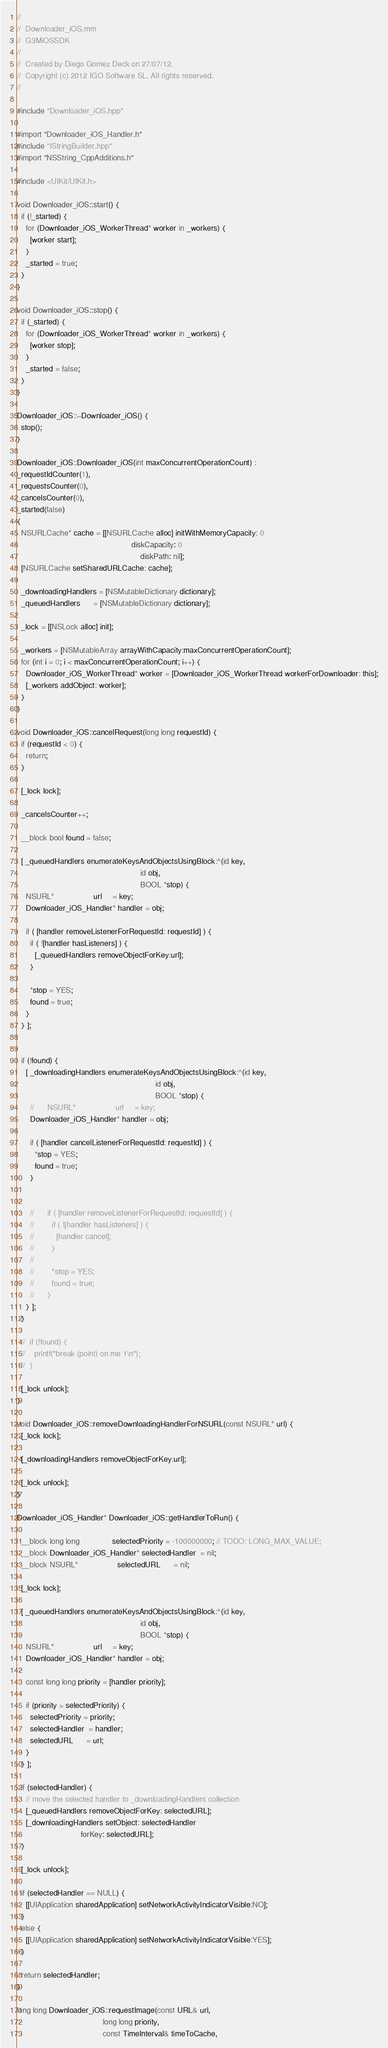<code> <loc_0><loc_0><loc_500><loc_500><_ObjectiveC_>//
//  Downloader_iOS.mm
//  G3MiOSSDK
//
//  Created by Diego Gomez Deck on 27/07/12.
//  Copyright (c) 2012 IGO Software SL. All rights reserved.
//

#include "Downloader_iOS.hpp"

#import "Downloader_iOS_Handler.h"
#include "IStringBuilder.hpp"
#import "NSString_CppAdditions.h"

#include <UIKit/UIKit.h>

void Downloader_iOS::start() {
  if (!_started) {
    for (Downloader_iOS_WorkerThread* worker in _workers) {
      [worker start];
    }
    _started = true;
  }
}

void Downloader_iOS::stop() {
  if (_started) {
    for (Downloader_iOS_WorkerThread* worker in _workers) {
      [worker stop];
    }
    _started = false;
  }
}

Downloader_iOS::~Downloader_iOS() {
  stop();
}

Downloader_iOS::Downloader_iOS(int maxConcurrentOperationCount) :
_requestIdCounter(1),
_requestsCounter(0),
_cancelsCounter(0),
_started(false)
{
  NSURLCache* cache = [[NSURLCache alloc] initWithMemoryCapacity: 0
                                                    diskCapacity: 0
                                                        diskPath: nil];
  [NSURLCache setSharedURLCache: cache];

  _downloadingHandlers = [NSMutableDictionary dictionary];
  _queuedHandlers      = [NSMutableDictionary dictionary];

  _lock = [[NSLock alloc] init];

  _workers = [NSMutableArray arrayWithCapacity:maxConcurrentOperationCount];
  for (int i = 0; i < maxConcurrentOperationCount; i++) {
    Downloader_iOS_WorkerThread* worker = [Downloader_iOS_WorkerThread workerForDownloader: this];
    [_workers addObject: worker];
  }
}

void Downloader_iOS::cancelRequest(long long requestId) {
  if (requestId < 0) {
    return;
  }

  [_lock lock];

  _cancelsCounter++;

  __block bool found = false;

  [ _queuedHandlers enumerateKeysAndObjectsUsingBlock:^(id key,
                                                        id obj,
                                                        BOOL *stop) {
    NSURL*                  url     = key;
    Downloader_iOS_Handler* handler = obj;

    if ( [handler removeListenerForRequestId: requestId] ) {
      if ( ![handler hasListeners] ) {
        [_queuedHandlers removeObjectForKey:url];
      }

      *stop = YES;
      found = true;
    }
  } ];


  if (!found) {
    [ _downloadingHandlers enumerateKeysAndObjectsUsingBlock:^(id key,
                                                               id obj,
                                                               BOOL *stop) {
      //      NSURL*                  url     = key;
      Downloader_iOS_Handler* handler = obj;

      if ( [handler cancelListenerForRequestId: requestId] ) {
        *stop = YES;
        found = true;
      }


      //      if ( [handler removeListenerForRequestId: requestId] ) {
      //        if ( ![handler hasListeners] ) {
      //          [handler cancel];
      //        }
      //
      //        *stop = YES;
      //        found = true;
      //      }
    } ];
  }

  //  if (!found) {
  //    printf("break (point) on me 1\n");
  //  }

  [_lock unlock];
}

void Downloader_iOS::removeDownloadingHandlerForNSURL(const NSURL* url) {
  [_lock lock];

  [_downloadingHandlers removeObjectForKey:url];

  [_lock unlock];
}

Downloader_iOS_Handler* Downloader_iOS::getHandlerToRun() {

  __block long long               selectedPriority = -100000000; // TODO: LONG_MAX_VALUE;
  __block Downloader_iOS_Handler* selectedHandler  = nil;
  __block NSURL*                  selectedURL      = nil;

  [_lock lock];

  [ _queuedHandlers enumerateKeysAndObjectsUsingBlock:^(id key,
                                                        id obj,
                                                        BOOL *stop) {
    NSURL*                  url     = key;
    Downloader_iOS_Handler* handler = obj;

    const long long priority = [handler priority];

    if (priority > selectedPriority) {
      selectedPriority = priority;
      selectedHandler  = handler;
      selectedURL      = url;
    }
  } ];

  if (selectedHandler) {
    // move the selected handler to _downloadingHandlers collection
    [_queuedHandlers removeObjectForKey: selectedURL];
    [_downloadingHandlers setObject: selectedHandler
                             forKey: selectedURL];
  }

  [_lock unlock];

  if (selectedHandler == NULL) {
    [[UIApplication sharedApplication] setNetworkActivityIndicatorVisible:NO];
  }
  else {
    [[UIApplication sharedApplication] setNetworkActivityIndicatorVisible:YES];
  }

  return selectedHandler;
}

long long Downloader_iOS::requestImage(const URL& url,
                                       long long priority,
                                       const TimeInterval& timeToCache,</code> 